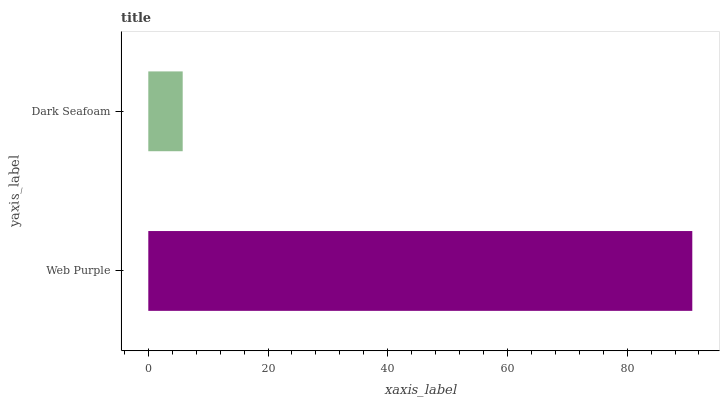Is Dark Seafoam the minimum?
Answer yes or no. Yes. Is Web Purple the maximum?
Answer yes or no. Yes. Is Dark Seafoam the maximum?
Answer yes or no. No. Is Web Purple greater than Dark Seafoam?
Answer yes or no. Yes. Is Dark Seafoam less than Web Purple?
Answer yes or no. Yes. Is Dark Seafoam greater than Web Purple?
Answer yes or no. No. Is Web Purple less than Dark Seafoam?
Answer yes or no. No. Is Web Purple the high median?
Answer yes or no. Yes. Is Dark Seafoam the low median?
Answer yes or no. Yes. Is Dark Seafoam the high median?
Answer yes or no. No. Is Web Purple the low median?
Answer yes or no. No. 